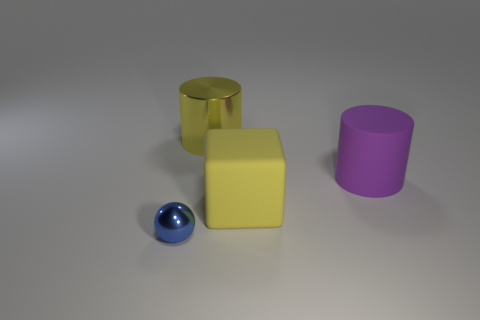Subtract all cubes. How many objects are left? 3 Subtract 1 blocks. How many blocks are left? 0 Subtract all blue cylinders. Subtract all brown blocks. How many cylinders are left? 2 Subtract all red blocks. How many yellow spheres are left? 0 Subtract all tiny brown shiny spheres. Subtract all metal things. How many objects are left? 2 Add 2 blue objects. How many blue objects are left? 3 Add 3 blue rubber cylinders. How many blue rubber cylinders exist? 3 Add 3 large purple cylinders. How many objects exist? 7 Subtract all yellow cylinders. How many cylinders are left? 1 Subtract 0 gray balls. How many objects are left? 4 